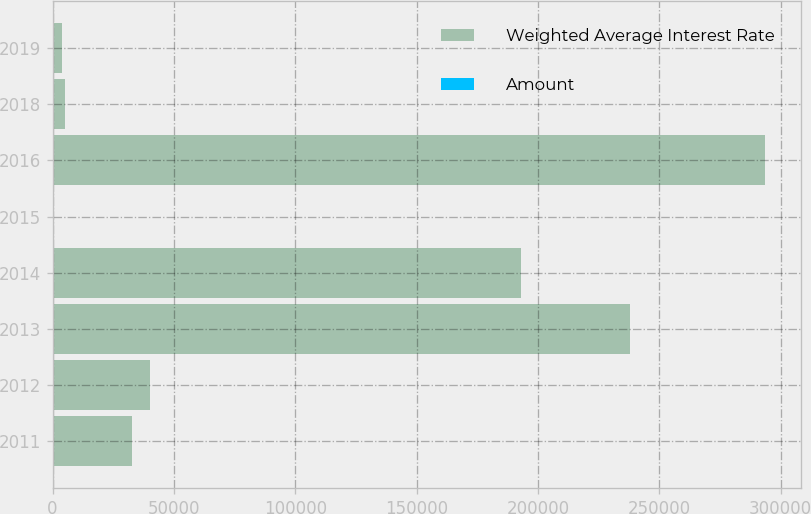Convert chart to OTSL. <chart><loc_0><loc_0><loc_500><loc_500><stacked_bar_chart><ecel><fcel>2011<fcel>2012<fcel>2013<fcel>2014<fcel>2015<fcel>2016<fcel>2018<fcel>2019<nl><fcel>Weighted Average Interest Rate<fcel>32806<fcel>40065<fcel>237700<fcel>193142<fcel>6.74<fcel>293650<fcel>5320<fcel>4096<nl><fcel>Amount<fcel>6.01<fcel>5.09<fcel>6<fcel>5.74<fcel>6.24<fcel>6.74<fcel>5.9<fcel>5.7<nl></chart> 